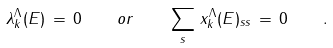Convert formula to latex. <formula><loc_0><loc_0><loc_500><loc_500>\lambda _ { k } ^ { \Lambda } ( E ) \, = \, 0 \quad o r \quad \sum _ { s } \, x _ { k } ^ { \Lambda } ( E ) _ { s s } \, = \, 0 \quad .</formula> 